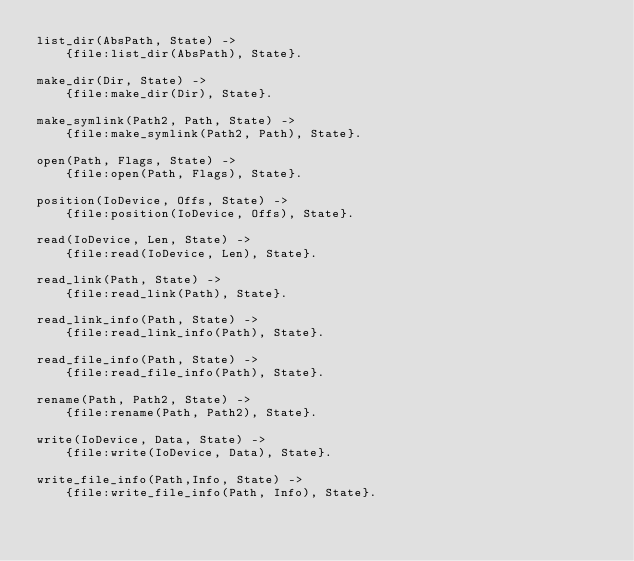<code> <loc_0><loc_0><loc_500><loc_500><_Erlang_>list_dir(AbsPath, State) ->
    {file:list_dir(AbsPath), State}.
     
make_dir(Dir, State) ->
    {file:make_dir(Dir), State}.
     
make_symlink(Path2, Path, State) ->
    {file:make_symlink(Path2, Path), State}.

open(Path, Flags, State) ->
    {file:open(Path, Flags), State}.
     
position(IoDevice, Offs, State) ->
    {file:position(IoDevice, Offs), State}.

read(IoDevice, Len, State) ->
    {file:read(IoDevice, Len), State}.
          
read_link(Path, State) ->
    {file:read_link(Path), State}.

read_link_info(Path, State) ->
    {file:read_link_info(Path), State}.
     
read_file_info(Path, State) ->
    {file:read_file_info(Path), State}.

rename(Path, Path2, State) ->
    {file:rename(Path, Path2), State}.

write(IoDevice, Data, State) ->
    {file:write(IoDevice, Data), State}.
     
write_file_info(Path,Info, State) ->
    {file:write_file_info(Path, Info), State}.
</code> 